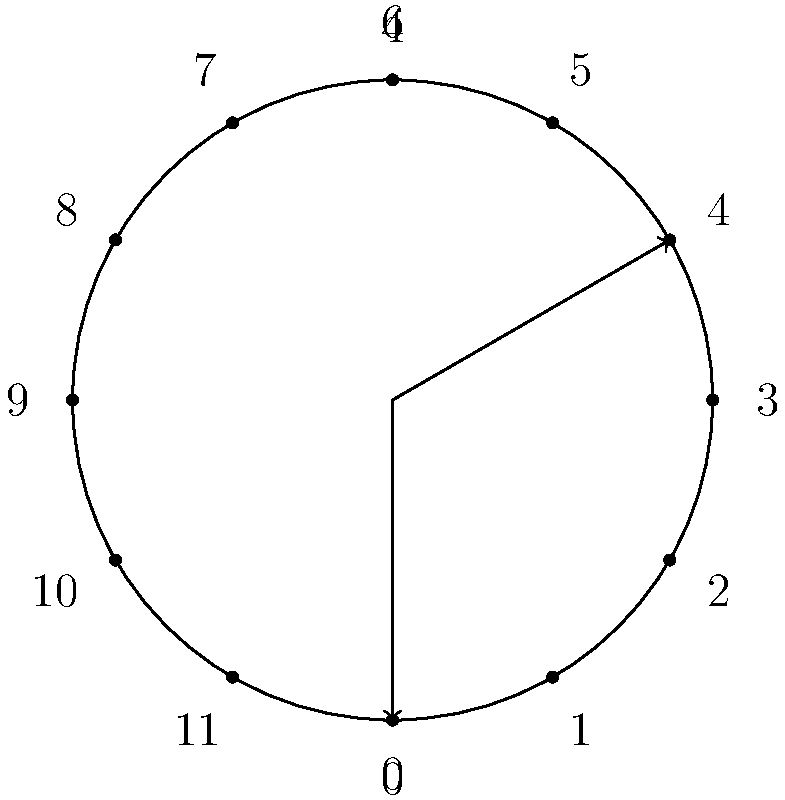In a San Francisco courthouse, court sessions are scheduled in 4-hour blocks. Using the cyclic group $\mathbb{Z}_{12}$ to represent a 12-hour clock, how would you represent the set of all possible starting times for these 4-hour court sessions? To solve this problem, we'll follow these steps:

1. Understand the cyclic group representation:
   - The clock is represented by $\mathbb{Z}_{12}$, where each number represents an hour.
   - The group operation is addition modulo 12.

2. Identify the pattern of 4-hour blocks:
   - Each session starts at some hour $h$ and ends 4 hours later.
   - In modular arithmetic, this is represented as $h + 4 \pmod{12}$.

3. Find all possible starting times:
   - Starting at 0 (12 AM), the sessions would be 0-4, 4-8, 8-12.
   - In modular arithmetic: $\{0, 4, 8\}$

4. Verify the solution:
   - These starting times indeed form a subgroup of $\mathbb{Z}_{12}$:
     * $0 + 4 \equiv 4 \pmod{12}$
     * $4 + 4 \equiv 8 \pmod{12}$
     * $8 + 4 \equiv 0 \pmod{12}$

5. Express the solution as a set:
   The set of all possible starting times is $\{0, 4, 8\}$.

This solution represents a cyclic subgroup of order 3 within $\mathbb{Z}_{12}$, generated by the element 4.
Answer: $\{0, 4, 8\}$ 